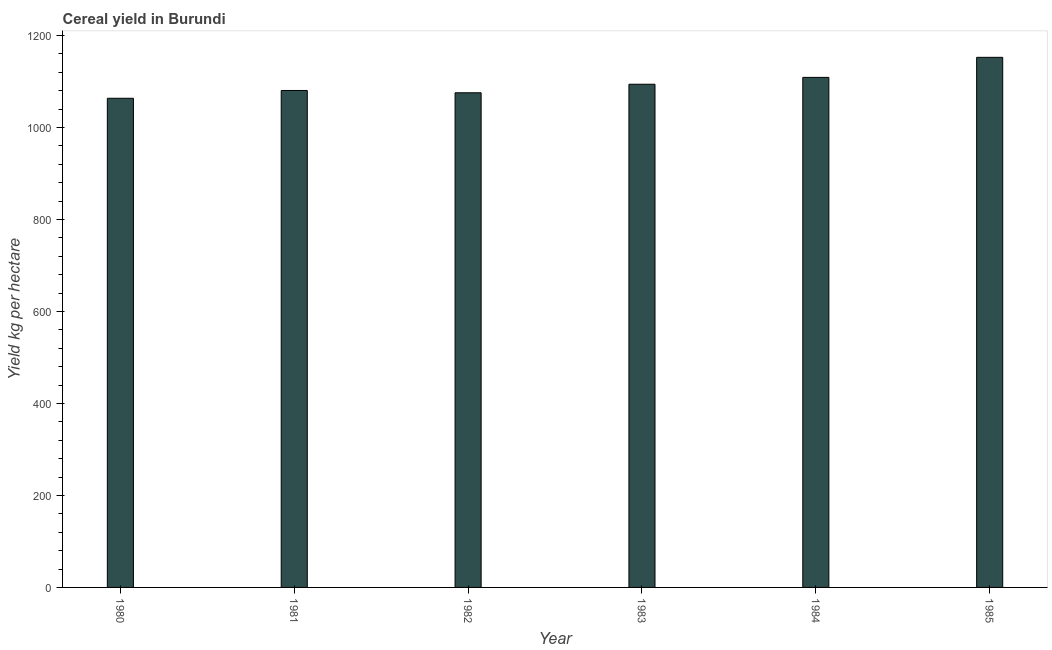What is the title of the graph?
Give a very brief answer. Cereal yield in Burundi. What is the label or title of the X-axis?
Make the answer very short. Year. What is the label or title of the Y-axis?
Make the answer very short. Yield kg per hectare. What is the cereal yield in 1980?
Make the answer very short. 1063.49. Across all years, what is the maximum cereal yield?
Your answer should be compact. 1152.5. Across all years, what is the minimum cereal yield?
Your response must be concise. 1063.49. What is the sum of the cereal yield?
Give a very brief answer. 6574.73. What is the difference between the cereal yield in 1980 and 1984?
Make the answer very short. -45.42. What is the average cereal yield per year?
Ensure brevity in your answer.  1095.79. What is the median cereal yield?
Provide a short and direct response. 1087.2. In how many years, is the cereal yield greater than 280 kg per hectare?
Provide a short and direct response. 6. Do a majority of the years between 1984 and 1983 (inclusive) have cereal yield greater than 440 kg per hectare?
Offer a very short reply. No. What is the ratio of the cereal yield in 1983 to that in 1985?
Offer a very short reply. 0.95. Is the cereal yield in 1983 less than that in 1984?
Your answer should be very brief. Yes. Is the difference between the cereal yield in 1984 and 1985 greater than the difference between any two years?
Keep it short and to the point. No. What is the difference between the highest and the second highest cereal yield?
Offer a terse response. 43.59. What is the difference between the highest and the lowest cereal yield?
Your response must be concise. 89. Are all the bars in the graph horizontal?
Provide a succinct answer. No. What is the Yield kg per hectare in 1980?
Your answer should be very brief. 1063.49. What is the Yield kg per hectare in 1981?
Your response must be concise. 1080.43. What is the Yield kg per hectare in 1982?
Give a very brief answer. 1075.43. What is the Yield kg per hectare in 1983?
Your answer should be compact. 1093.98. What is the Yield kg per hectare in 1984?
Offer a very short reply. 1108.91. What is the Yield kg per hectare in 1985?
Your answer should be compact. 1152.5. What is the difference between the Yield kg per hectare in 1980 and 1981?
Give a very brief answer. -16.93. What is the difference between the Yield kg per hectare in 1980 and 1982?
Provide a succinct answer. -11.93. What is the difference between the Yield kg per hectare in 1980 and 1983?
Keep it short and to the point. -30.48. What is the difference between the Yield kg per hectare in 1980 and 1984?
Your answer should be compact. -45.42. What is the difference between the Yield kg per hectare in 1980 and 1985?
Offer a terse response. -89. What is the difference between the Yield kg per hectare in 1981 and 1982?
Give a very brief answer. 5. What is the difference between the Yield kg per hectare in 1981 and 1983?
Keep it short and to the point. -13.55. What is the difference between the Yield kg per hectare in 1981 and 1984?
Provide a succinct answer. -28.48. What is the difference between the Yield kg per hectare in 1981 and 1985?
Offer a terse response. -72.07. What is the difference between the Yield kg per hectare in 1982 and 1983?
Offer a terse response. -18.55. What is the difference between the Yield kg per hectare in 1982 and 1984?
Give a very brief answer. -33.48. What is the difference between the Yield kg per hectare in 1982 and 1985?
Ensure brevity in your answer.  -77.07. What is the difference between the Yield kg per hectare in 1983 and 1984?
Offer a very short reply. -14.94. What is the difference between the Yield kg per hectare in 1983 and 1985?
Your answer should be very brief. -58.52. What is the difference between the Yield kg per hectare in 1984 and 1985?
Your answer should be compact. -43.59. What is the ratio of the Yield kg per hectare in 1980 to that in 1983?
Offer a terse response. 0.97. What is the ratio of the Yield kg per hectare in 1980 to that in 1984?
Provide a succinct answer. 0.96. What is the ratio of the Yield kg per hectare in 1980 to that in 1985?
Your response must be concise. 0.92. What is the ratio of the Yield kg per hectare in 1981 to that in 1983?
Offer a terse response. 0.99. What is the ratio of the Yield kg per hectare in 1981 to that in 1984?
Make the answer very short. 0.97. What is the ratio of the Yield kg per hectare in 1981 to that in 1985?
Your answer should be compact. 0.94. What is the ratio of the Yield kg per hectare in 1982 to that in 1985?
Offer a terse response. 0.93. What is the ratio of the Yield kg per hectare in 1983 to that in 1984?
Provide a succinct answer. 0.99. What is the ratio of the Yield kg per hectare in 1983 to that in 1985?
Provide a short and direct response. 0.95. 